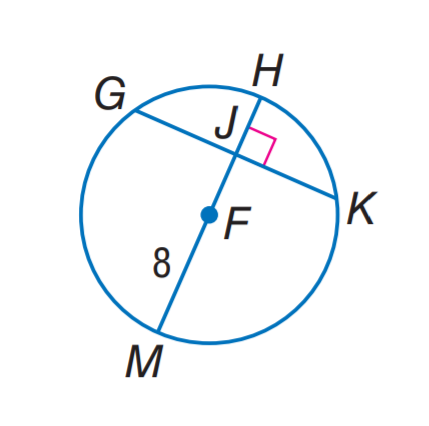Answer the mathemtical geometry problem and directly provide the correct option letter.
Question: In \odot F, G K = 14 and m \widehat G H K = 142. Find m \widehat K M.
Choices: A: 99 B: 109 C: 113 D: 142 B 